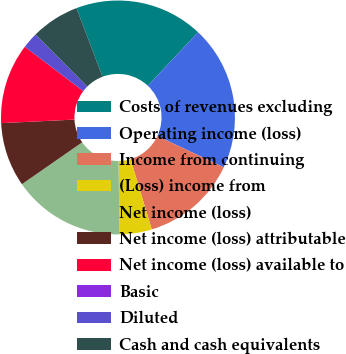Convert chart. <chart><loc_0><loc_0><loc_500><loc_500><pie_chart><fcel>Costs of revenues excluding<fcel>Operating income (loss)<fcel>Income from continuing<fcel>(Loss) income from<fcel>Net income (loss)<fcel>Net income (loss) attributable<fcel>Net income (loss) available to<fcel>Basic<fcel>Diluted<fcel>Cash and cash equivalents<nl><fcel>17.78%<fcel>20.0%<fcel>13.33%<fcel>4.45%<fcel>15.55%<fcel>8.89%<fcel>11.11%<fcel>0.0%<fcel>2.22%<fcel>6.67%<nl></chart> 